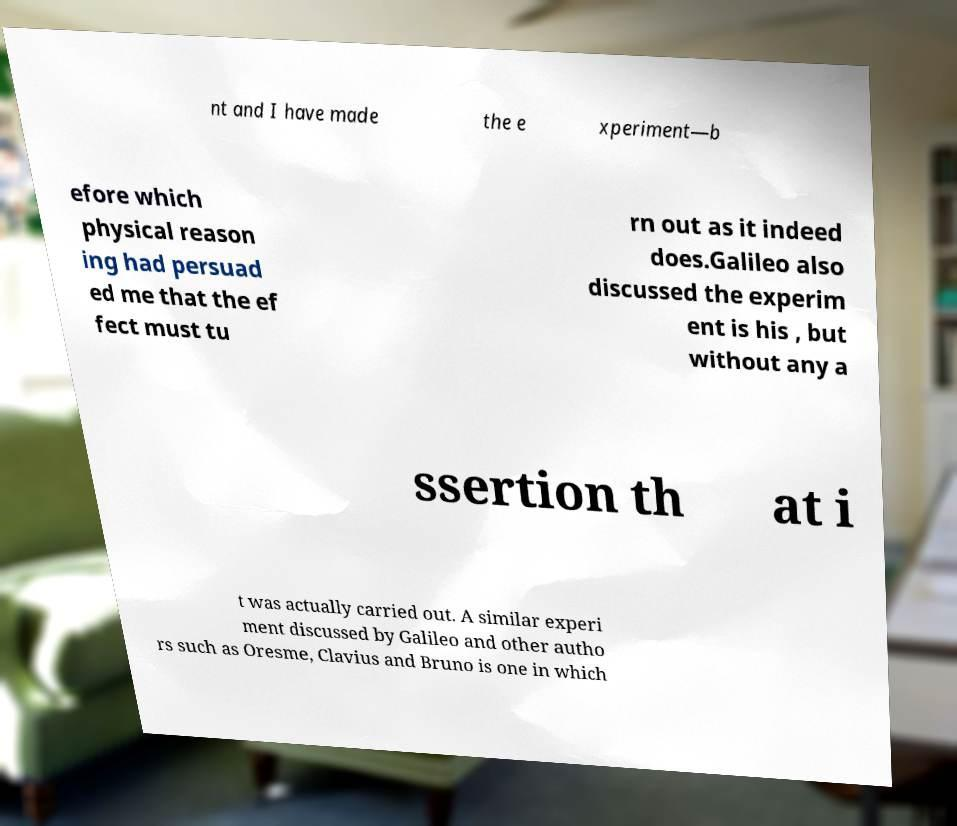Can you read and provide the text displayed in the image?This photo seems to have some interesting text. Can you extract and type it out for me? nt and I have made the e xperiment—b efore which physical reason ing had persuad ed me that the ef fect must tu rn out as it indeed does.Galileo also discussed the experim ent is his , but without any a ssertion th at i t was actually carried out. A similar experi ment discussed by Galileo and other autho rs such as Oresme, Clavius and Bruno is one in which 